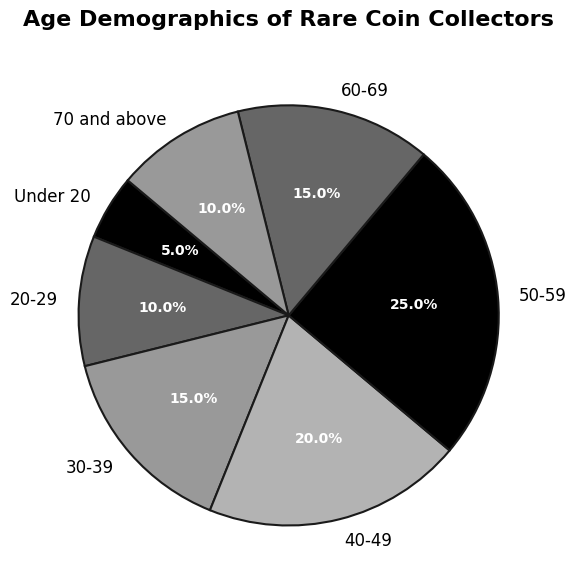Which age group has the highest percentage of collectors? Looking at the pie chart, the wedge representing the "50-59" age group is the largest, indicating this group has the highest percentage.
Answer: 50-59 Which age groups together make up more than 60% of the collectors? Adding the percentages of the largest contributing age groups: 50-59 (25%), 40-49 (20%), and 30-39 (15%), we get 60%.
Answer: 50-59, 40-49, 30-39 How many age groups have more than 15% of collectors? Observing the pie chart, the age groups 50-59 (25%) and 40-49 (20%) are more than 15%. The 60-69 group has exactly 15%, so it doesn't count.
Answer: 2 Which age group makes up exactly 15% of collectors? Reading the individual labels on the pie chart, the "30-39" and "60-69" groups both show 15%.
Answer: 30-39 and 60-69 Compare the percentages of collectors under 20 and those 70 and above. Which is higher? Both the "Under 20" and "70 and above" age groups have a wedge of 10%, indicating they are equal.
Answer: They are equal What is the total percentage of collectors aged 20-29 and 70 and above? Summing up the percentages: 20-29 (10%) + 70 and above (10%) = 20%.
Answer: 20% How does the percentage of collectors aged 60-69 compare to those aged 30-39? Both age groups have the same percentage, as indicated by the similar-sized wedges labelled 15%.
Answer: Equal If the age groups 50-59 and 60-69 are combined, what percentage of collectors do they represent? Adding the percentages of the two age groups: 50-59 (25%) + 60-69 (15%) = 40%.
Answer: 40% Which age group has the smallest percentage of collectors, and what is that percentage? The "Under 20" age group has the smallest slice of the pie, indicating it has the smallest percentage at 5%.
Answer: Under 20, 5% What's the difference in percentage between the 40-49 and 20-29 age groups? Subtracting the percentages: 40-49 (20%) - 20-29 (10%) = 10%.
Answer: 10% 